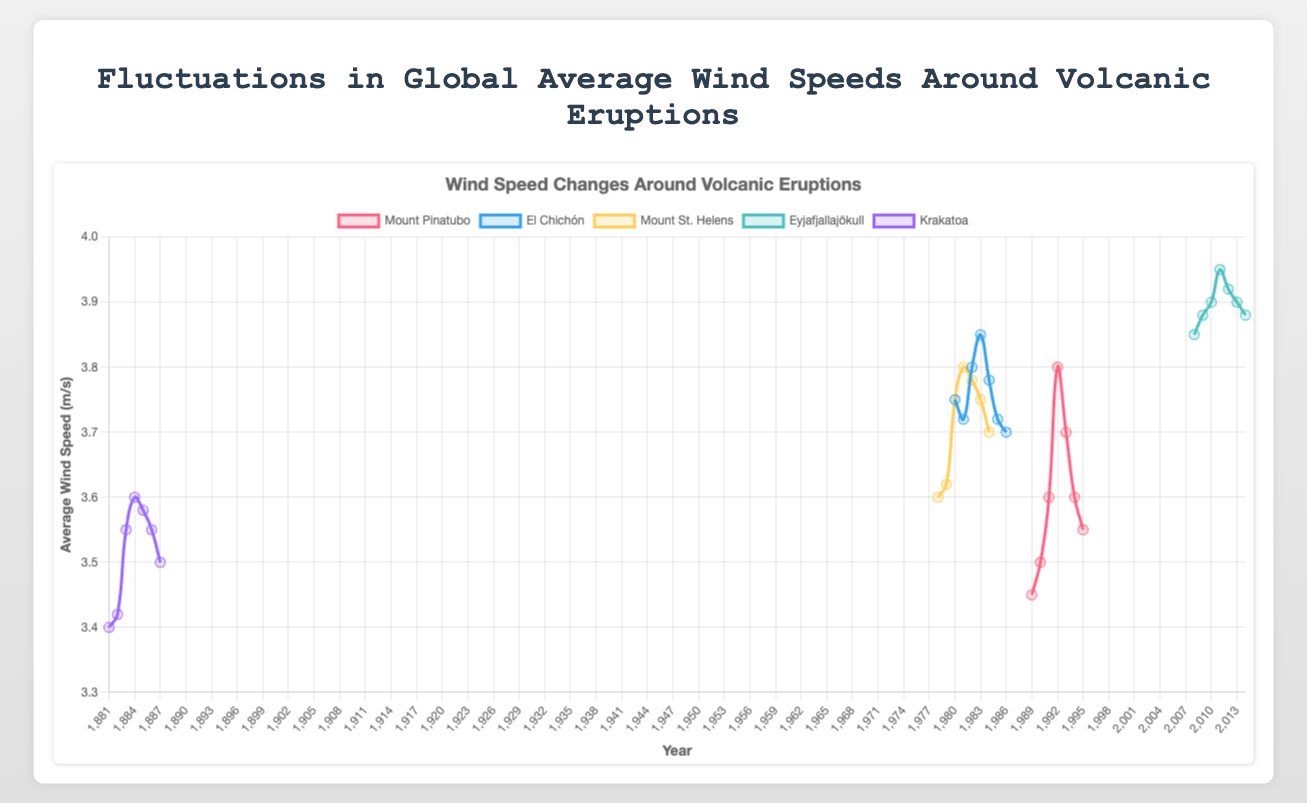What year did the Mount Pinatubo eruption occur? The chart indicates the eruption years with a vertical line. For Mount Pinatubo, this line is at 1991.
Answer: 1991 What was the average wind speed in the year following the Eyjafjallajökull eruption? The Eyjafjallajökull eruption occurred in 2010. Looking at the chart for the year 2011, we see the average wind speed was 3.95 m/s.
Answer: 3.95 m/s Which volcanic eruption showed the highest peak in wind speed after its eruption year? By comparing the peaks of the curves following each eruption year, we observe that Mount Pinatubo has the highest average wind speed of 3.8 m/s in 1992.
Answer: Mount Pinatubo What is the percentage increase in wind speed from the year before to the year after the Mount St. Helens eruption? The eruption happened in 1980. The wind speed in 1979 was 3.62 m/s, and in 1981 it was 3.80 m/s. The percentage increase is ((3.80 - 3.62) / 3.62) * 100%.
Answer: 4.97% Compare the average wind speed trend of Krakatoa and El Chichón in the first two years following their eruptions. Krakatoa's wind speeds post-eruption were 3.60 m/s and 3.58 m/s, while El Chichón's were 3.85 m/s and 3.78 m/s. El Chichón had a higher and more significant decline while Krakatoa's remained relatively stable.
Answer: El Chichón declined more and started higher Was there any volcanic eruption where the wind speed remained constant in the years after the eruption? None of the curves representing the volcanic eruptions show a constant wind speed; there are fluctuations in all cases.
Answer: No What is the difference in average wind speed in the eruption year of Eyjafjallajökull and the following year? In 2010, Eyjafjallajökull's wind speed was 3.90 m/s. In 2011, it was 3.95 m/s. The difference is 3.95 - 3.90 = 0.05 m/s.
Answer: 0.05 m/s Rank the eruptions based on the average wind speed one year after the eruption, from highest to lowest. After one year: Eyjafjallajökull (3.95 m/s), Mount St. Helens (3.80 m/s), Mount Pinatubo (3.80 m/s), El Chichón (3.85 m/s), Krakatoa (3.60 m/s).
Answer: Eyjafjallajökull, El Chichón, Mount St. Helens, Mount Pinatubo, Krakatoa 